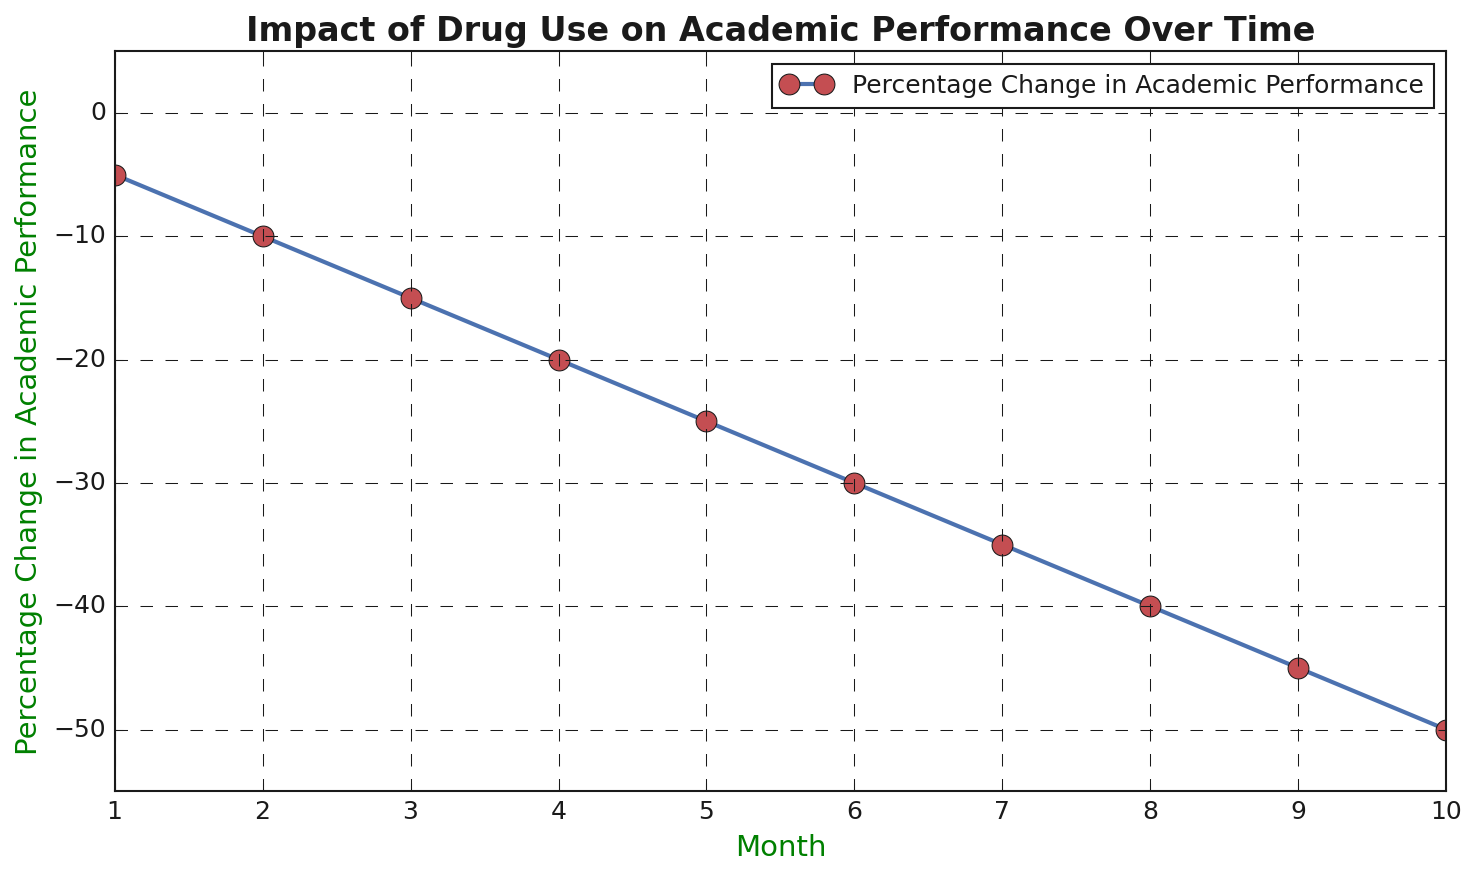What is the trend shown in the graph? The graph shows a steady decline in academic performance percentage change over ten months. Every month, the academic performance percentage change is decreasing by 5%.
Answer: Steady decline What is the percentage change in academic performance at month 5? In month 5, the percentage change in academic performance is -25%, as shown by the corresponding data point on the graph.
Answer: -25% By how much does the academic performance percentage change from month 1 to month 10? From month 1 to month 10, the percentage change in academic performance goes from -5% to -50%. The difference is -50% - (-5%) = -45%.
Answer: -45% Is the academic performance in month 3 better or worse than in month 6, and by how much? The academic performance in month 3 is -15% and in month 6 is -30%. Performance in month 3 is better. The difference is -15% - (-30%) = 15%.
Answer: Better by 15% What is the average percentage change in academic performance over the 10 months? To find the average, sum all values: -5% -10% -15% -20% -25% -30% -35% -40% -45% -50% = -275%. Then, divide by the number of months: -275% / 10 = -27.5%.
Answer: -27.5% How does the percentage change in academic performance in month 2 compare to month 7? In month 2, it is -10%, and in month 7, it is -35%. Month 2 shows better performance by a difference of -10% - (-35%) = 25%.
Answer: Month 2 is better by 25% What month shows the steepest decline compared to the previous month? Each month shows a consistent decline of 5%. Therefore, no single month shows a steeper decline compared to others, as the decline rate is constant.
Answer: Consistent decline How much is the percentage difference in academic performance from the midpoint (month 5) to the endpoint (month 10)? At month 5, it's -25%. At month 10, it's -50%. The difference is -50% - (-25%) = -25%.
Answer: -25% Which month first shows a more than 20% decline in academic performance? Month 4 shows a -20% decline. Month 5, with -25%, is the first to show more than a 20% decline.
Answer: Month 5 What visual elements are used to indicate data points on the graph? The graph uses blue lines connecting red-circled markers to represent each month’s data point, and a title and axis labels that are colored green.
Answer: Blue lines, red markers, green labels 